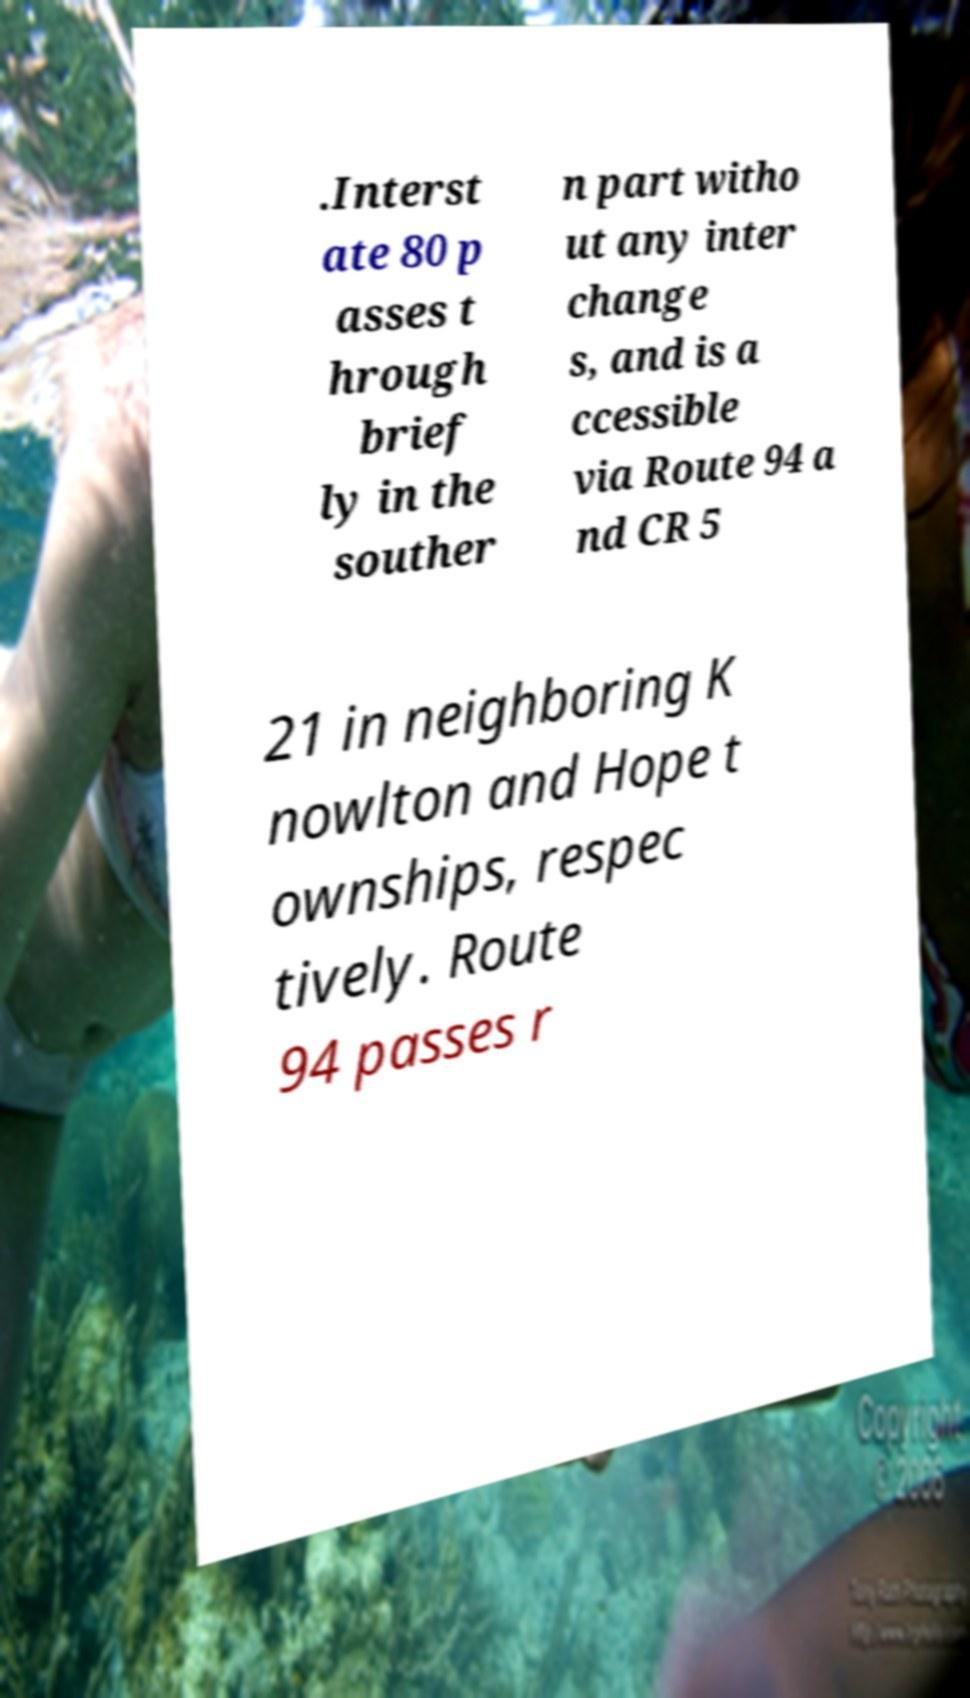I need the written content from this picture converted into text. Can you do that? .Interst ate 80 p asses t hrough brief ly in the souther n part witho ut any inter change s, and is a ccessible via Route 94 a nd CR 5 21 in neighboring K nowlton and Hope t ownships, respec tively. Route 94 passes r 